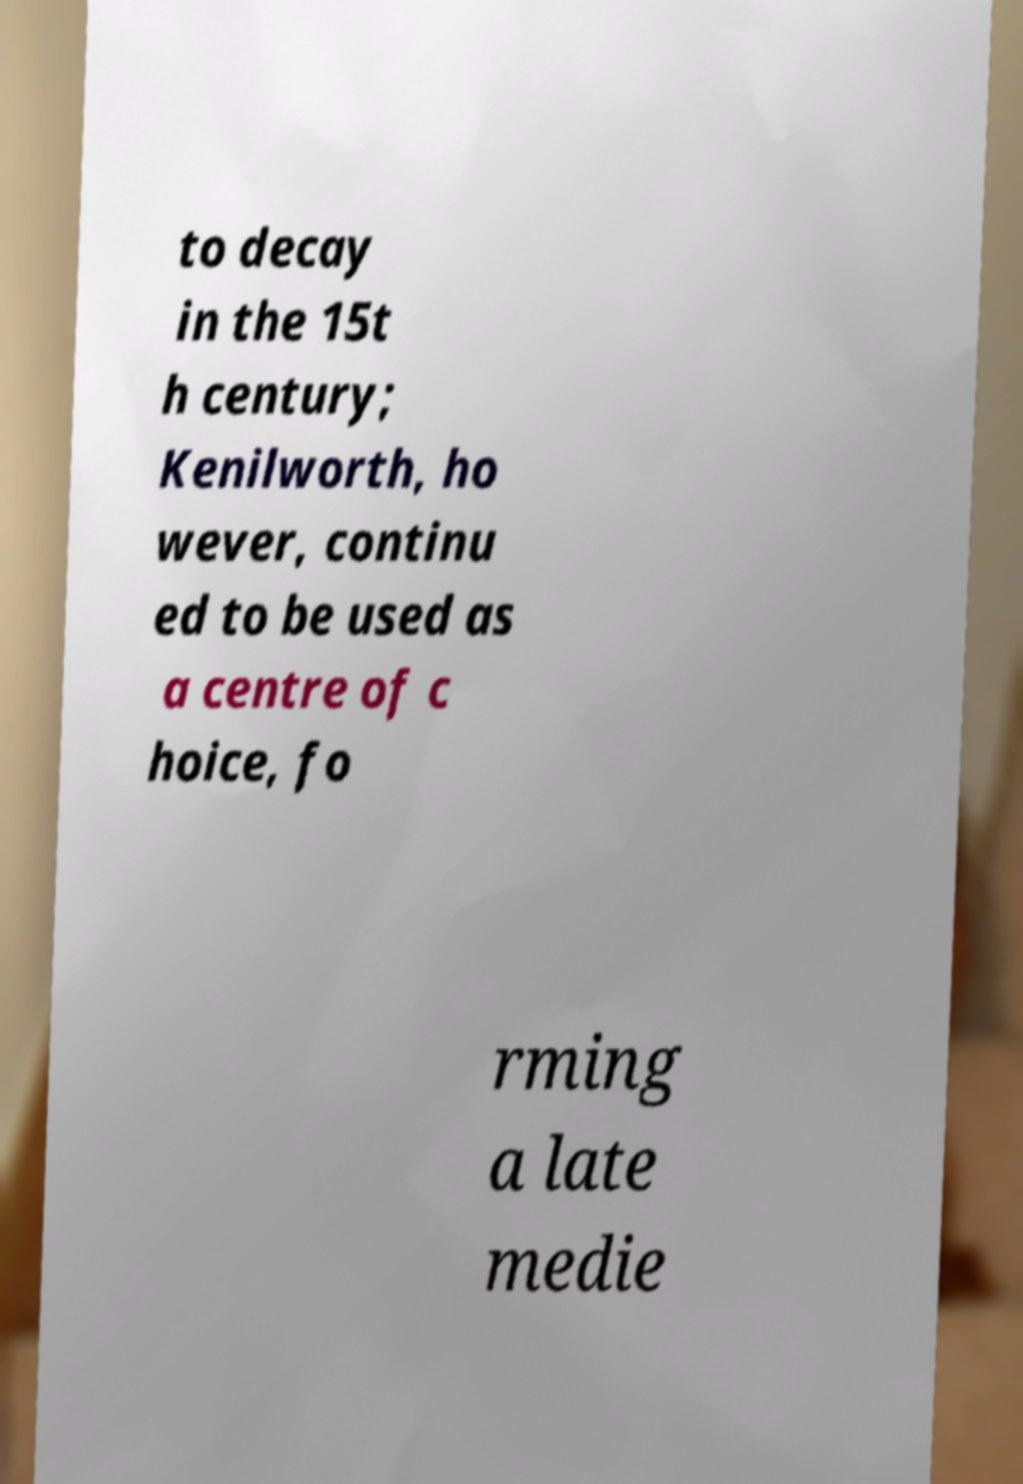Can you accurately transcribe the text from the provided image for me? to decay in the 15t h century; Kenilworth, ho wever, continu ed to be used as a centre of c hoice, fo rming a late medie 